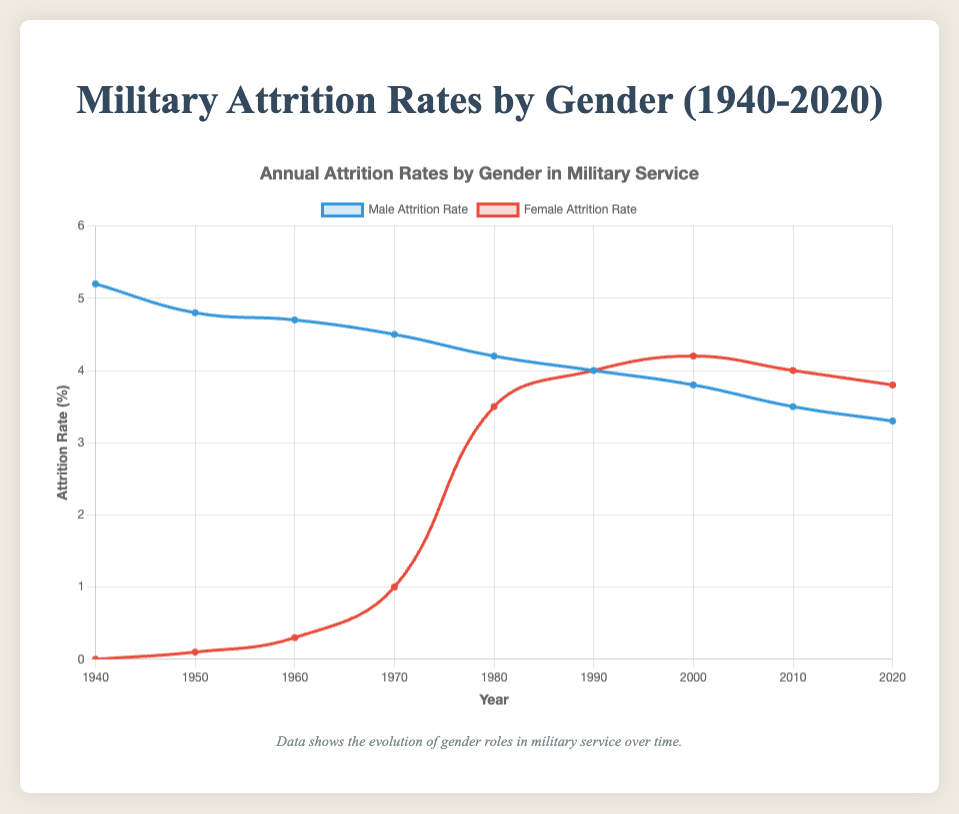Which gender had a higher attrition rate in 1990? Looking at the figure, we see that the male and female attrition rates are equal in 1990. Both rates are plotted at the same level.
Answer: Male and Female What is the average attrition rate for males from 1940 to 2020? Summing up the male attrition rates: 5.2 + 4.8 + 4.7 + 4.5 + 4.2 + 4.0 + 3.8 + 3.5 + 3.3 = 37.0, then dividing by the number of years (9): 37.0 / 9
Answer: 4.11 Between 1960 and 1970, how did the female attrition rate change? The female attrition rate increased from 0.3 in 1960 to 1.0 in 1970 as shown by the upward trend on the graph.
Answer: Increased Which year marked the closest attrition rates between genders? The year 1990 shows the closest attrition rates, as both the male and female rates are the same at 4.0. This can be determined by identifying the point where the two graphs intersect.
Answer: 1990 By how much did the female attrition rate exceed the male rate in 2000? In 2000, the female attrition rate was 4.2, and the male attrition rate was 3.8. The difference is 4.2 - 3.8
Answer: 0.4 What is the trend observed in the male attrition rate from 1940 to 2020? The male attrition rate shows a consistent downward trend from 5.2 in 1940 to 3.3 in 2020 as depicted by the descending line on the graph.
Answer: Decreasing In which decade did the female attrition rate increase the most rapidly? The steepest increase in the female attrition rate happened between 1970 and 1980, rising from 1.0 to 3.5. This can be spotted by the steepest slope on the female attrition line.
Answer: 1970 to 1980 What is the difference in attrition rates between males and females in 1980? The male attrition rate in 1980 was 4.2, and the female attrition rate was also 3.5. The difference is 4.2 - 3.5
Answer: 0.7 How did the male attrition rate change from 2010 to 2020? From 2010 to 2020, the male attrition rate decreased from 3.5 to 3.3. This can be observed from the downward slope of the male attrition line during this period.
Answer: Decreased 